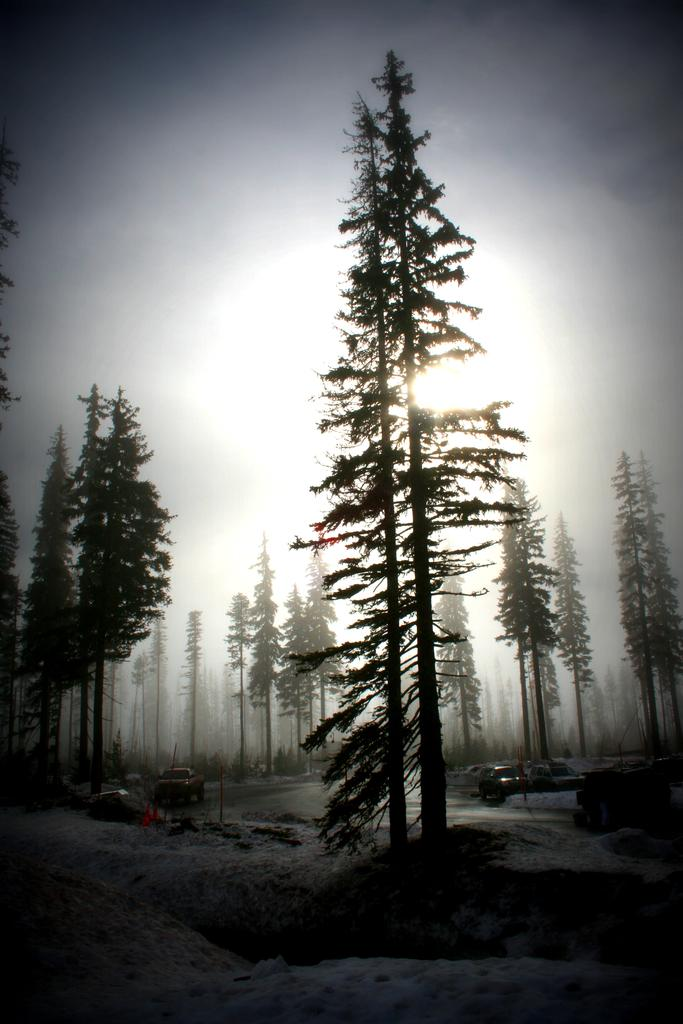What type of vegetation can be seen in the image? There are trees in the image. What type of man-made objects are present in the image? There are cars in the image. What can be seen in the background of the image? The sky is visible in the background of the image. What type of ray is swimming in the image? There is no ray present in the image; it features trees, cars, and the sky. What type of basket is being used to transport the cars in the image? There is no basket present in the image, and the cars are not being transported. 